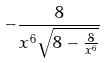Convert formula to latex. <formula><loc_0><loc_0><loc_500><loc_500>- \frac { 8 } { x ^ { 6 } \sqrt { 8 - \frac { 8 } { x ^ { 6 } } } }</formula> 